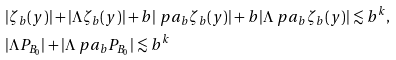Convert formula to latex. <formula><loc_0><loc_0><loc_500><loc_500>& | \zeta _ { b } ( y ) | + | \Lambda \zeta _ { b } ( y ) | + b | \ p a _ { b } \zeta _ { b } ( y ) | + b | \Lambda \ p a _ { b } \zeta _ { b } ( y ) | \lesssim b ^ { k } , \\ & | \Lambda P _ { B _ { 0 } } | + | \Lambda \ p a _ { b } P _ { B _ { 0 } } | \lesssim b ^ { k }</formula> 